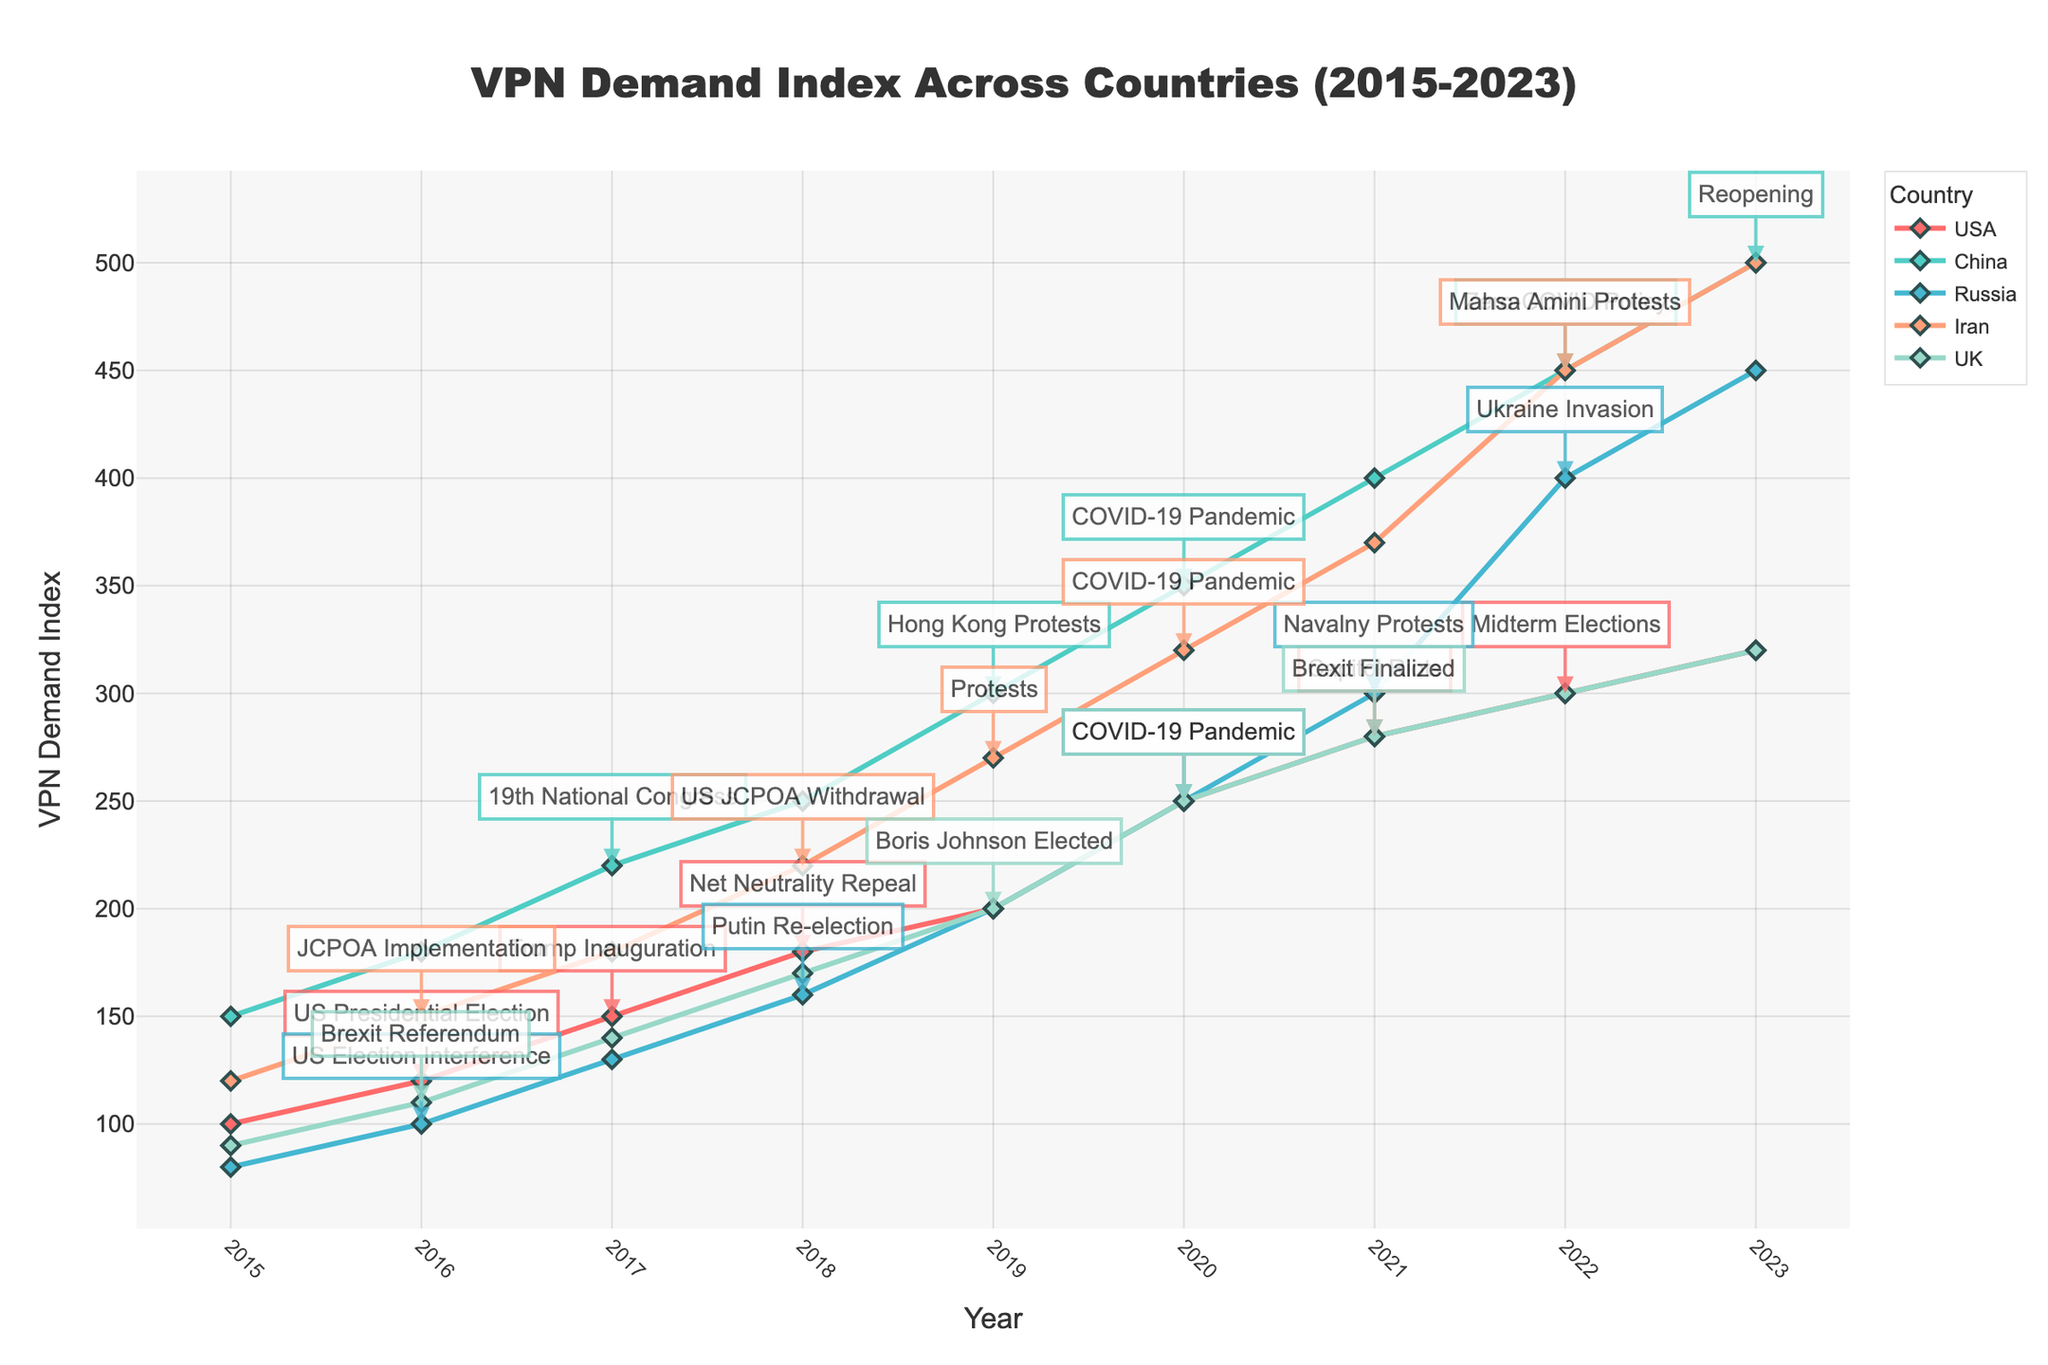What year did the USA see the highest increase in VPN demand due to a political event? The USA saw the highest increase in VPN demand in 2020, coinciding with the COVID-19 Pandemic. This is shown by the large step up in the line corresponding to the USA in the chart.
Answer: 2020 Which country had the highest VPN demand in 2023? In the figure, the line corresponding to China reaches the highest point in 2023 compared to other countries. This indicates that China had the highest VPN demand in that year.
Answer: China Compare the VPN demand increase from 2015 to 2023 between the USA and Iran. Which country saw a larger increase? From the chart, the USA's VPN demand index increased from 100 in 2015 to 320 in 2023, a difference of 220. Iran's index increased from 120 in 2015 to 500 in 2023, a difference of 380. Therefore, Iran saw a larger increase in VPN demand.
Answer: Iran In what year did Russia's VPN demand index reach 400, and what was the related political event? The chart indicates that Russia's VPN demand index reached 400 in 2022, the same year as the Ukraine Invasion.
Answer: 2022 Which country's VPN demand increased the most during the COVID-19 Pandemic, from 2019 to 2020? Comparing the increases from 2019 to 2020 for all countries: USA (200 to 250), China (300 to 350), Russia (200 to 250), Iran (270 to 320), and the UK (200 to 250). China's increase of 50 points is the highest.
Answer: China How many major political events were annotated in China's VPN demand trend from 2015 to 2023? The chart shows annotations for 4 major political events for China: 19th National Congress (2017), Hong Kong Protests (2019), COVID-19 Pandemic (2020), and Zero-COVID Policy (2022).
Answer: 4 Which country's VPN demand showed the most steady increase without a significant dip from 2015 to 2023? The chart lines corresponding to each country show various trends. China's VPN demand line depicts a steady increase without notable dips or drops across the years mentioned.
Answer: China 